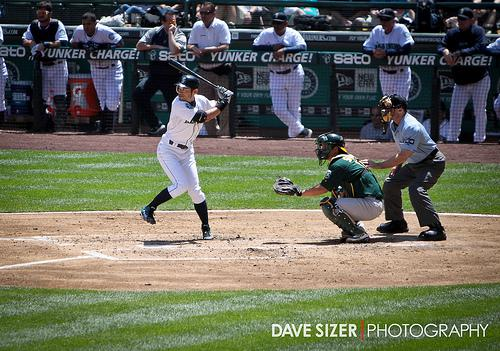Question: what two word are written over and over again on the fence?
Choices:
A. Yunker charge.
B. Danger.
C. Warning.
D. Paint me.
Answer with the letter. Answer: A Question: what leg of the player batting is off the ground?
Choices:
A. Left.
B. On facing east.
C. On to the south.
D. Right.
Answer with the letter. Answer: D Question: how many men are leaning on the fence?
Choices:
A. 8.
B. 9.
C. 7.
D. 10.
Answer with the letter. Answer: C Question: who is wearing a green shirt?
Choices:
A. Boy.
B. Waiter.
C. Teacher.
D. Catcher.
Answer with the letter. Answer: D Question: why is there a person behind the catcher?
Choices:
A. Umpire.
B. Filming.
C. Learning.
D. To call strikes.
Answer with the letter. Answer: D Question: where was this picture taken?
Choices:
A. Zoo.
B. Park.
C. Baseball field.
D. Beach.
Answer with the letter. Answer: C Question: what is the first name of the person who took this picture?
Choices:
A. Jessica.
B. Peggy.
C. Mike.
D. Dave.
Answer with the letter. Answer: D 